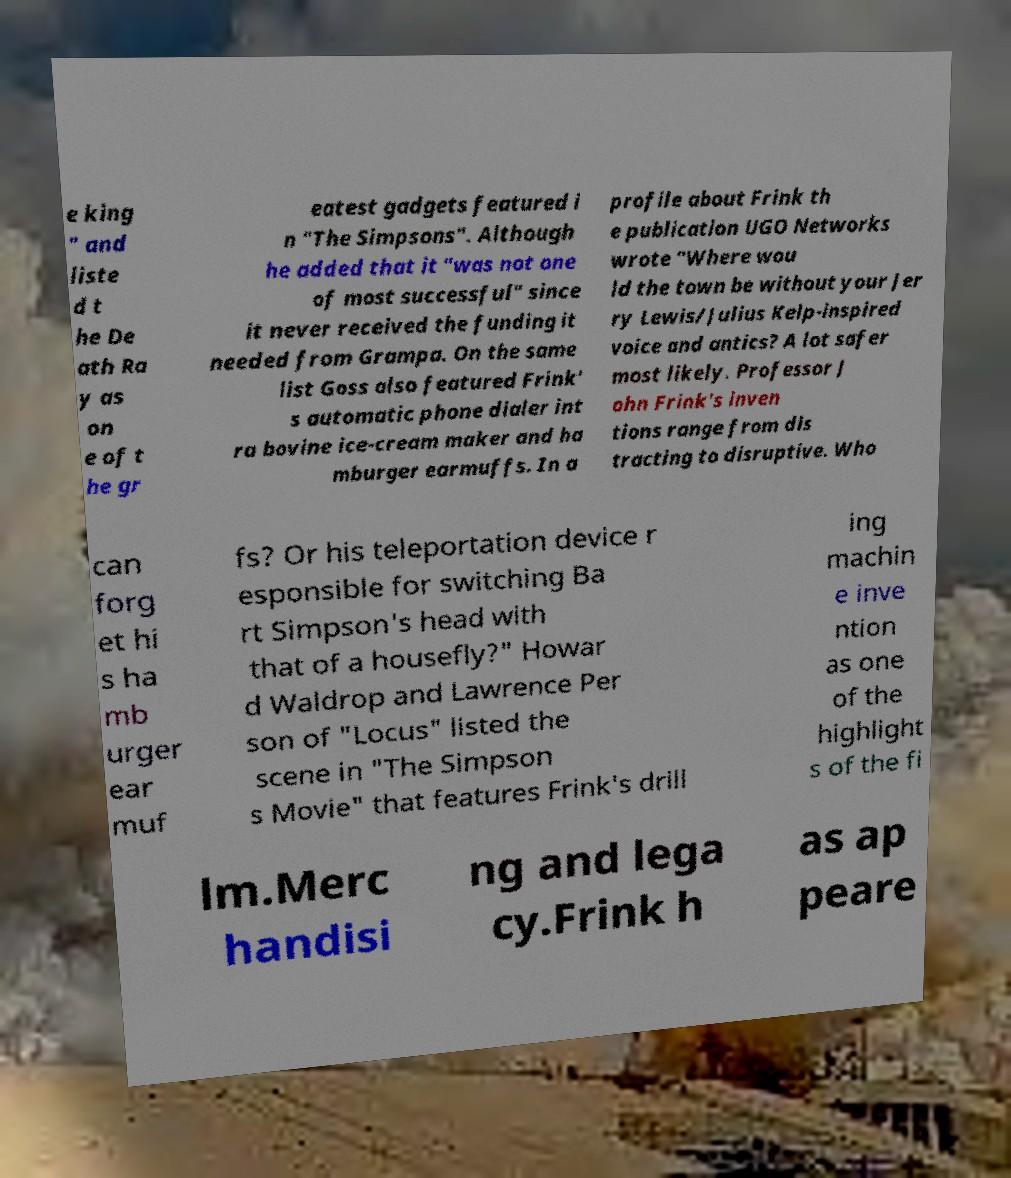Could you assist in decoding the text presented in this image and type it out clearly? e king " and liste d t he De ath Ra y as on e of t he gr eatest gadgets featured i n "The Simpsons". Although he added that it "was not one of most successful" since it never received the funding it needed from Grampa. On the same list Goss also featured Frink' s automatic phone dialer int ra bovine ice-cream maker and ha mburger earmuffs. In a profile about Frink th e publication UGO Networks wrote "Where wou ld the town be without your Jer ry Lewis/Julius Kelp-inspired voice and antics? A lot safer most likely. Professor J ohn Frink's inven tions range from dis tracting to disruptive. Who can forg et hi s ha mb urger ear muf fs? Or his teleportation device r esponsible for switching Ba rt Simpson's head with that of a housefly?" Howar d Waldrop and Lawrence Per son of "Locus" listed the scene in "The Simpson s Movie" that features Frink's drill ing machin e inve ntion as one of the highlight s of the fi lm.Merc handisi ng and lega cy.Frink h as ap peare 